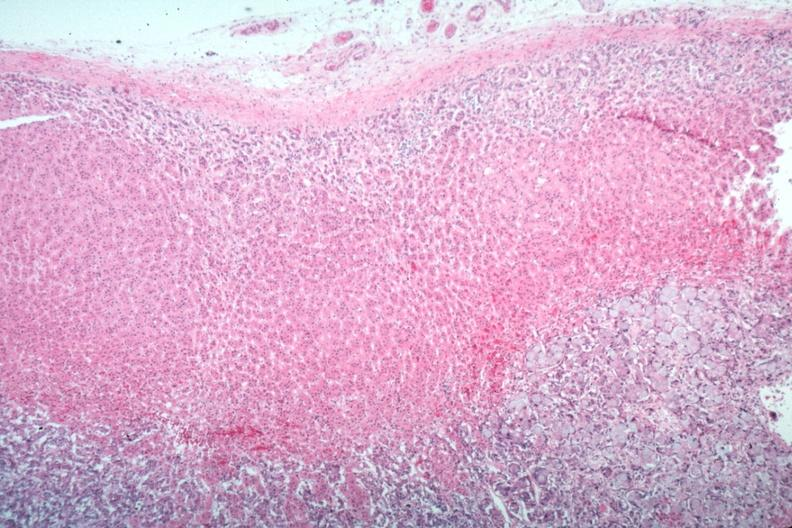where is this part in the figure?
Answer the question using a single word or phrase. Endocrine system 